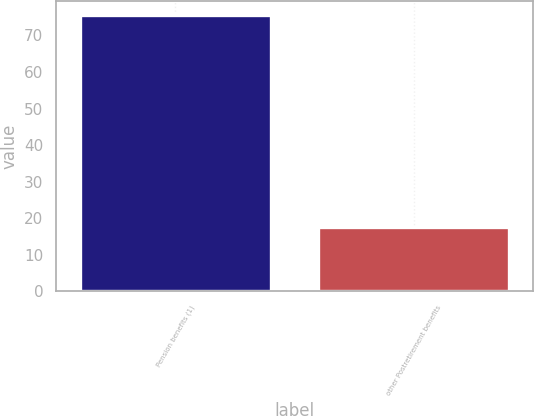Convert chart to OTSL. <chart><loc_0><loc_0><loc_500><loc_500><bar_chart><fcel>Pension benefits (1)<fcel>other Postretirement benefits<nl><fcel>75.7<fcel>17.6<nl></chart> 